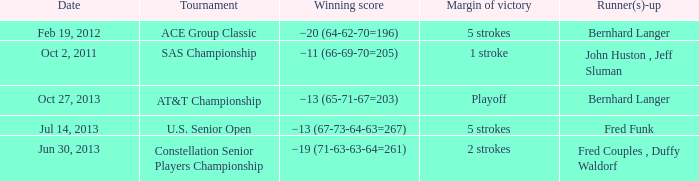Who's the Runner(s)-up with a Winning score of −19 (71-63-63-64=261)? Fred Couples , Duffy Waldorf. 